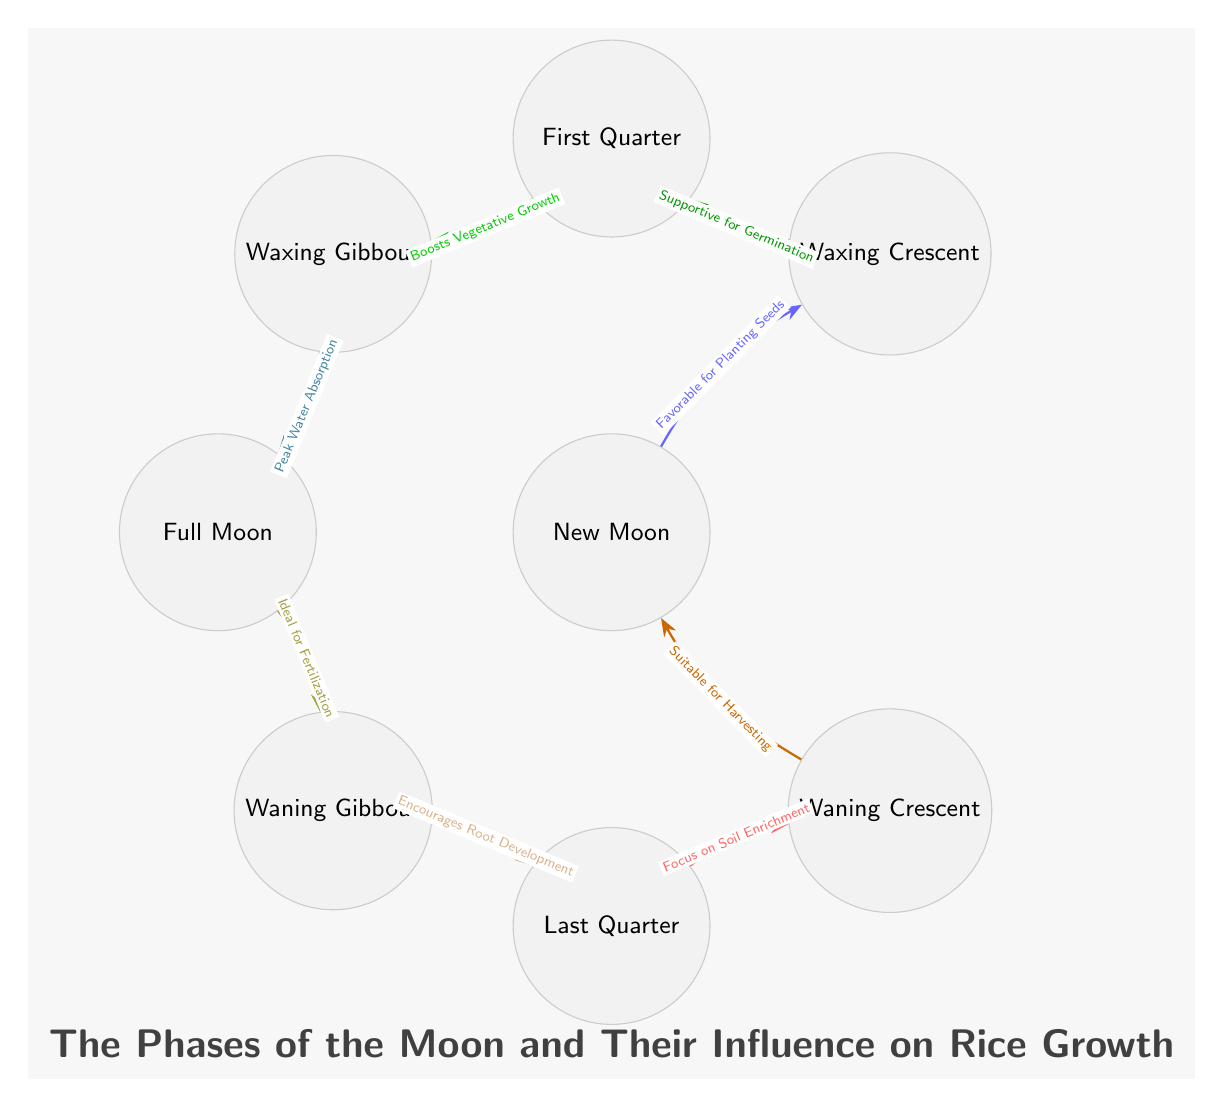What is the first phase of the Moon depicted in the diagram? The diagram displays the phases in a circular format starting from the New Moon and moving clockwise. The first node in this flow, located at the center, is labeled "New Moon."
Answer: New Moon How many phases of the Moon are shown in the diagram? Counting the nodes in the diagram, there are eight distinct phases of the Moon presented, from New Moon to Waning Crescent.
Answer: 8 Which phase is characterized as "Ideal for Fertilization"? The label directly connected to the Full Moon node states that it is "Ideal for Fertilization." This is derived from the diagram's edge leading from Full Moon to Waning Gibbous.
Answer: Full Moon What is the relationship between the Waxing Gibbous and the Full Moon? The edge connecting Waxing Gibbous to Full Moon indicates that Waxing Gibbous leads to the Full Moon phase. The Full Moon represents the peak for many agricultural practices.
Answer: Waxing Gibbous to Full Moon What does the label on the edge leading from Last Quarter to Waning Crescent indicate? Following the edge from Last Quarter, the label states "Focus on Soil Enrichment." This indicates the intended agricultural practice during this phase before transitioning back to New Moon.
Answer: Focus on Soil Enrichment Which lunar phase is suitable for harvesting according to the diagram? The diagram shows that the phase labeled "Waning Crescent" is described as "Suitable for Harvesting." This is indicated by the edge leading into New Moon.
Answer: Waning Crescent What is the function of the Full Moon phase in terms of water absorption? The edge from Waxing Gibbous to Full Moon specifies "Peak Water Absorption," indicating that this phase plays a critical role in the rice growth cycle in terms of water management.
Answer: Peak Water Absorption Which phase supports germination? The diagram shows that the edge from Waxing Crescent to First Quarter is labeled “Supportive for Germination,” indicating this phase’s importance for seed sprouting.
Answer: Waxing Crescent 